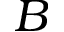Convert formula to latex. <formula><loc_0><loc_0><loc_500><loc_500>B</formula> 